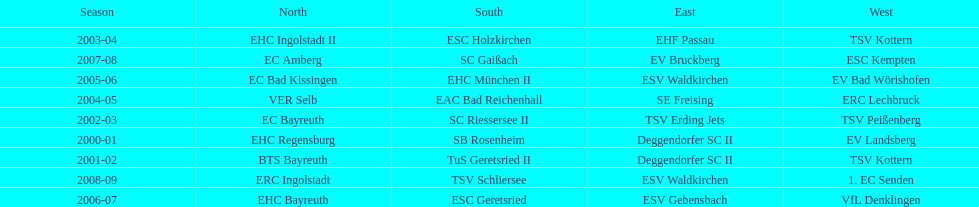The last team to win the west? 1. EC Senden. 